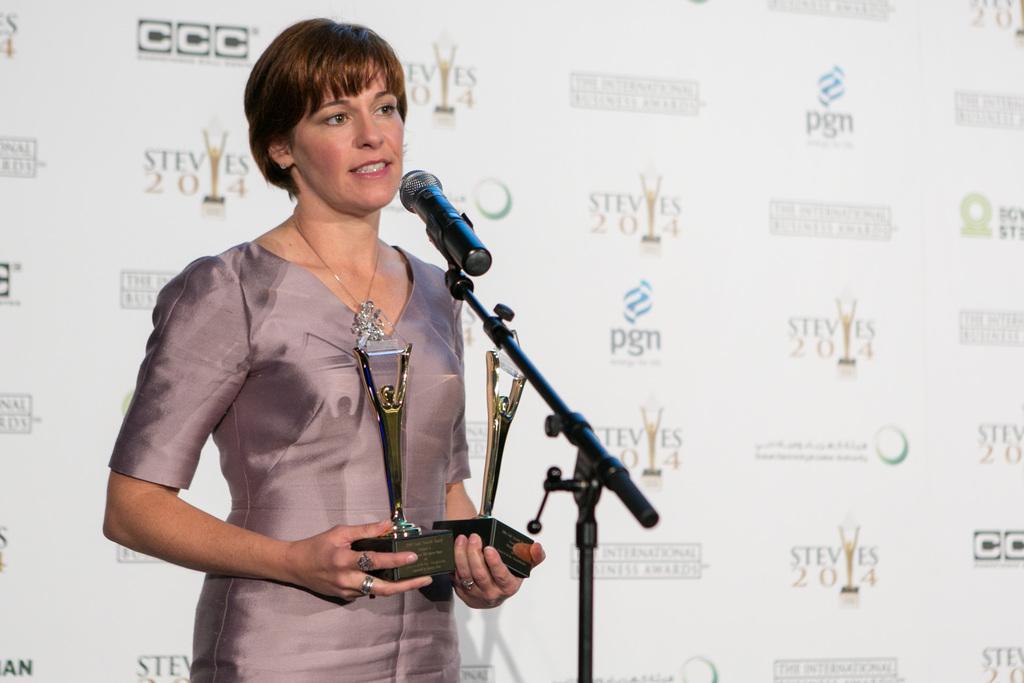Can you describe this image briefly? In this picture we can see a woman, she is standing in front of microphone and she is holding shields, behind her we can see a hoarding. 